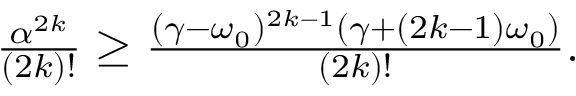Convert formula to latex. <formula><loc_0><loc_0><loc_500><loc_500>\begin{array} { r } { \frac { \alpha ^ { 2 k } } { ( 2 k ) ! } \geq \frac { ( \gamma - \omega _ { 0 } ) ^ { 2 k - 1 } ( \gamma + ( 2 k - 1 ) \omega _ { 0 } ) } { ( 2 k ) ! } . } \end{array}</formula> 